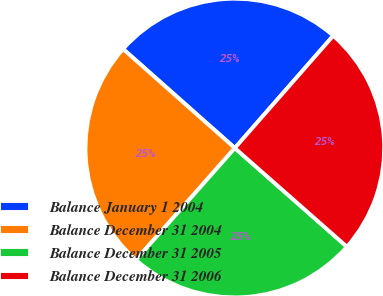<chart> <loc_0><loc_0><loc_500><loc_500><pie_chart><fcel>Balance January 1 2004<fcel>Balance December 31 2004<fcel>Balance December 31 2005<fcel>Balance December 31 2006<nl><fcel>24.91%<fcel>25.02%<fcel>25.03%<fcel>25.04%<nl></chart> 